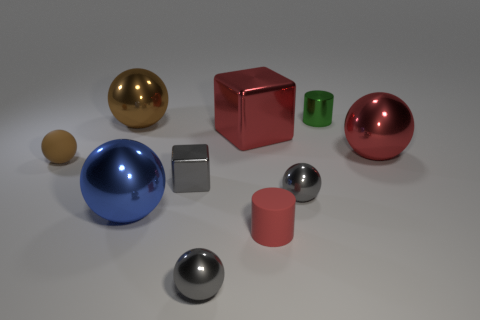Subtract all blue spheres. How many spheres are left? 5 Subtract all gray shiny spheres. How many spheres are left? 4 Subtract 3 spheres. How many spheres are left? 3 Subtract all purple spheres. Subtract all blue cylinders. How many spheres are left? 6 Subtract all balls. How many objects are left? 4 Subtract 1 red cylinders. How many objects are left? 9 Subtract all metallic objects. Subtract all gray shiny balls. How many objects are left? 0 Add 2 large brown metal spheres. How many large brown metal spheres are left? 3 Add 5 large blue balls. How many large blue balls exist? 6 